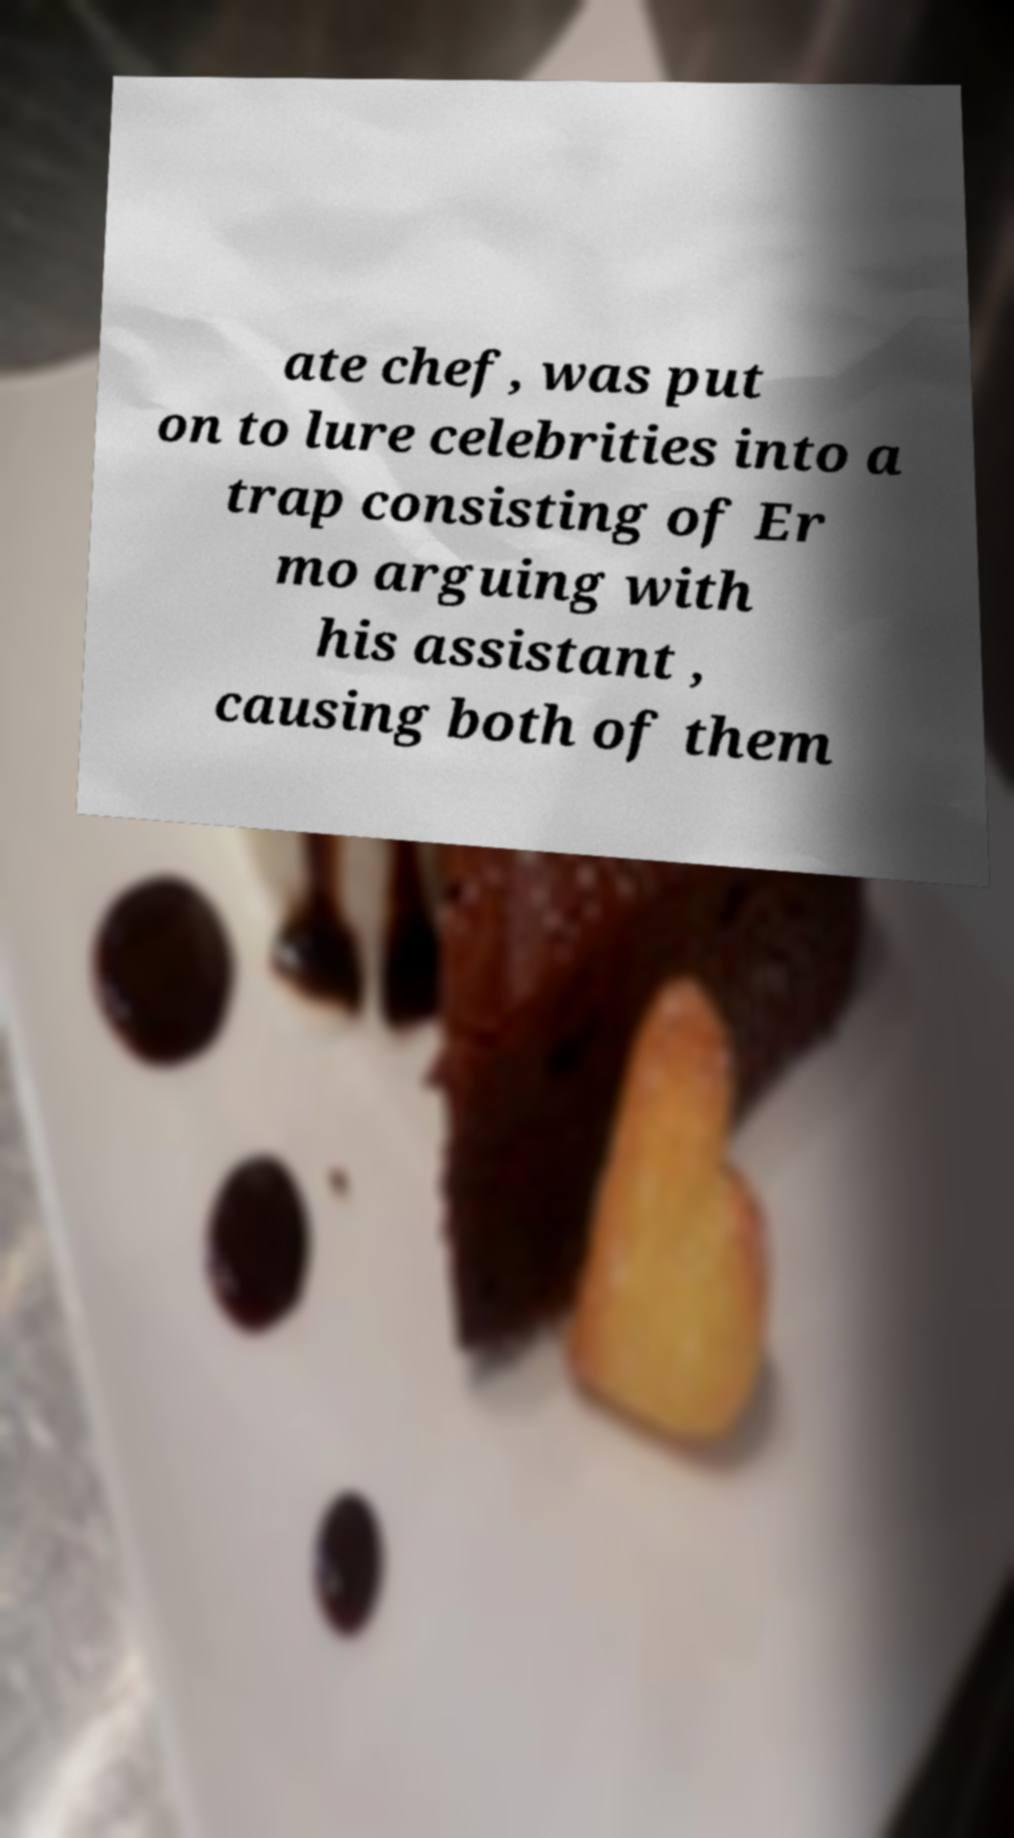Please identify and transcribe the text found in this image. ate chef, was put on to lure celebrities into a trap consisting of Er mo arguing with his assistant , causing both of them 